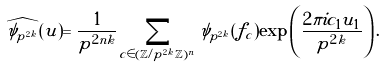<formula> <loc_0><loc_0><loc_500><loc_500>\widehat { \psi _ { p ^ { 2 k } } } ( u ) = \frac { 1 } { p ^ { 2 n k } } \sum _ { c \in ( \mathbb { Z } / p ^ { 2 k } \mathbb { Z } ) ^ { n } } \psi _ { p ^ { 2 k } } ( f _ { c } ) \exp \left ( \frac { 2 \pi i c _ { 1 } u _ { 1 } } { p ^ { 2 k } } \right ) .</formula> 